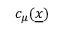<formula> <loc_0><loc_0><loc_500><loc_500>c _ { \mu } ( \underline { x } )</formula> 